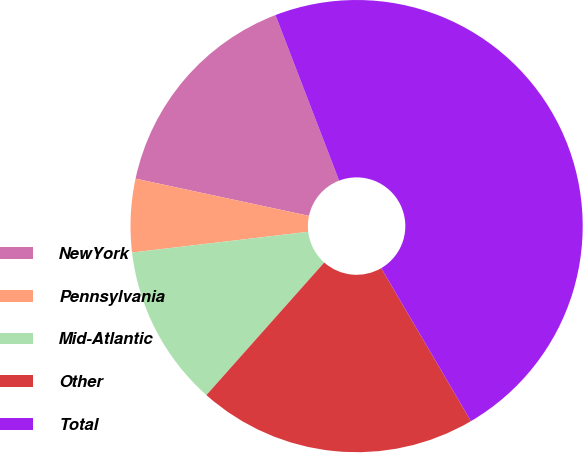Convert chart. <chart><loc_0><loc_0><loc_500><loc_500><pie_chart><fcel>NewYork<fcel>Pennsylvania<fcel>Mid-Atlantic<fcel>Other<fcel>Total<nl><fcel>15.79%<fcel>5.23%<fcel>11.57%<fcel>20.0%<fcel>47.4%<nl></chart> 